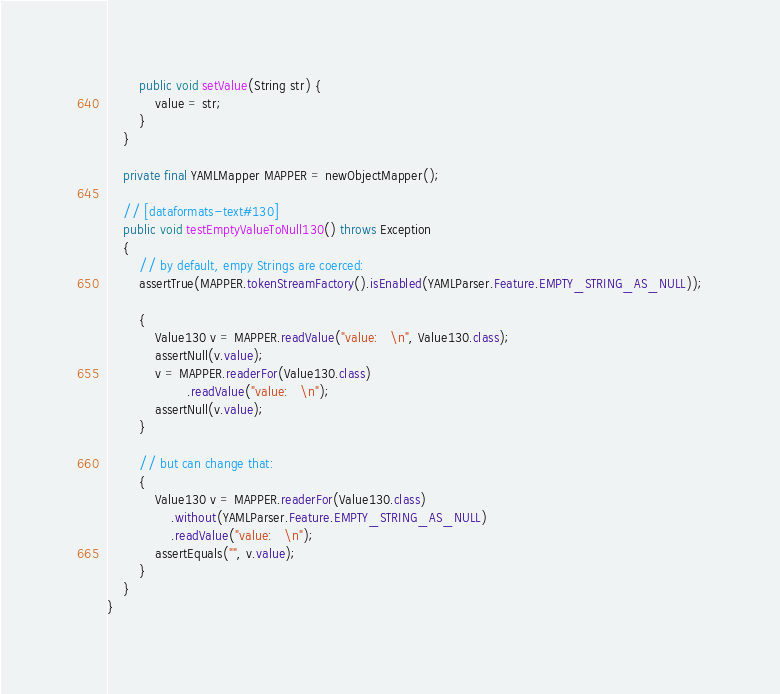Convert code to text. <code><loc_0><loc_0><loc_500><loc_500><_Java_>        public void setValue(String str) {
            value = str;
        }
    }

    private final YAMLMapper MAPPER = newObjectMapper();

    // [dataformats-text#130]
    public void testEmptyValueToNull130() throws Exception
    {
        // by default, empy Strings are coerced:
        assertTrue(MAPPER.tokenStreamFactory().isEnabled(YAMLParser.Feature.EMPTY_STRING_AS_NULL));

        {
            Value130 v = MAPPER.readValue("value:   \n", Value130.class);
            assertNull(v.value);
            v = MAPPER.readerFor(Value130.class)
                    .readValue("value:   \n");
            assertNull(v.value);
        }

        // but can change that:
        {
            Value130 v = MAPPER.readerFor(Value130.class)
                .without(YAMLParser.Feature.EMPTY_STRING_AS_NULL)
                .readValue("value:   \n");
            assertEquals("", v.value);
        }
    }
}
</code> 